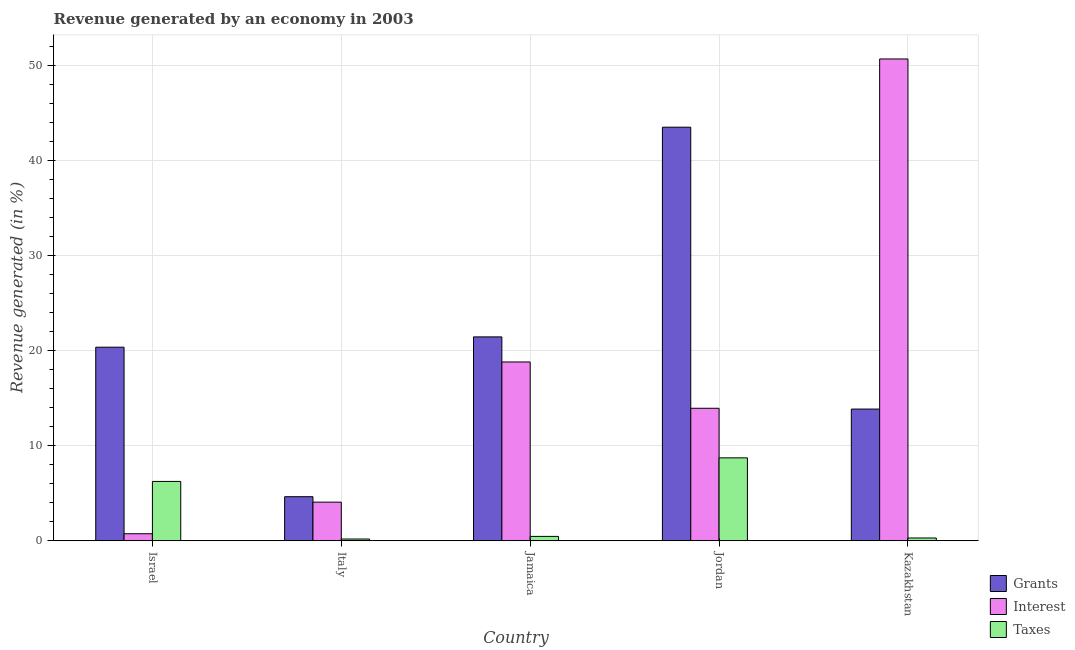Are the number of bars per tick equal to the number of legend labels?
Give a very brief answer. Yes. How many bars are there on the 2nd tick from the right?
Ensure brevity in your answer.  3. What is the label of the 5th group of bars from the left?
Offer a very short reply. Kazakhstan. In how many cases, is the number of bars for a given country not equal to the number of legend labels?
Give a very brief answer. 0. What is the percentage of revenue generated by interest in Kazakhstan?
Provide a short and direct response. 50.67. Across all countries, what is the maximum percentage of revenue generated by taxes?
Offer a terse response. 8.72. Across all countries, what is the minimum percentage of revenue generated by interest?
Ensure brevity in your answer.  0.73. In which country was the percentage of revenue generated by interest maximum?
Ensure brevity in your answer.  Kazakhstan. What is the total percentage of revenue generated by grants in the graph?
Ensure brevity in your answer.  103.77. What is the difference between the percentage of revenue generated by taxes in Italy and that in Kazakhstan?
Give a very brief answer. -0.11. What is the difference between the percentage of revenue generated by grants in Italy and the percentage of revenue generated by taxes in Jamaica?
Provide a succinct answer. 4.18. What is the average percentage of revenue generated by grants per country?
Ensure brevity in your answer.  20.75. What is the difference between the percentage of revenue generated by grants and percentage of revenue generated by interest in Jamaica?
Provide a short and direct response. 2.64. What is the ratio of the percentage of revenue generated by grants in Israel to that in Jordan?
Your response must be concise. 0.47. Is the percentage of revenue generated by taxes in Israel less than that in Jamaica?
Your response must be concise. No. Is the difference between the percentage of revenue generated by grants in Israel and Italy greater than the difference between the percentage of revenue generated by interest in Israel and Italy?
Your response must be concise. Yes. What is the difference between the highest and the second highest percentage of revenue generated by grants?
Offer a terse response. 22.06. What is the difference between the highest and the lowest percentage of revenue generated by interest?
Keep it short and to the point. 49.94. In how many countries, is the percentage of revenue generated by interest greater than the average percentage of revenue generated by interest taken over all countries?
Your answer should be very brief. 2. Is the sum of the percentage of revenue generated by grants in Italy and Jamaica greater than the maximum percentage of revenue generated by interest across all countries?
Provide a short and direct response. No. What does the 1st bar from the left in Jordan represents?
Your answer should be compact. Grants. What does the 1st bar from the right in Jordan represents?
Give a very brief answer. Taxes. What is the difference between two consecutive major ticks on the Y-axis?
Your answer should be compact. 10. Are the values on the major ticks of Y-axis written in scientific E-notation?
Give a very brief answer. No. Does the graph contain any zero values?
Provide a succinct answer. No. How many legend labels are there?
Your answer should be compact. 3. How are the legend labels stacked?
Keep it short and to the point. Vertical. What is the title of the graph?
Ensure brevity in your answer.  Revenue generated by an economy in 2003. Does "Tertiary" appear as one of the legend labels in the graph?
Provide a succinct answer. No. What is the label or title of the Y-axis?
Offer a terse response. Revenue generated (in %). What is the Revenue generated (in %) of Grants in Israel?
Keep it short and to the point. 20.35. What is the Revenue generated (in %) of Interest in Israel?
Your response must be concise. 0.73. What is the Revenue generated (in %) of Taxes in Israel?
Ensure brevity in your answer.  6.24. What is the Revenue generated (in %) of Grants in Italy?
Your answer should be compact. 4.63. What is the Revenue generated (in %) of Interest in Italy?
Give a very brief answer. 4.06. What is the Revenue generated (in %) in Taxes in Italy?
Make the answer very short. 0.18. What is the Revenue generated (in %) of Grants in Jamaica?
Provide a succinct answer. 21.44. What is the Revenue generated (in %) in Interest in Jamaica?
Your answer should be compact. 18.8. What is the Revenue generated (in %) in Taxes in Jamaica?
Make the answer very short. 0.45. What is the Revenue generated (in %) of Grants in Jordan?
Provide a succinct answer. 43.49. What is the Revenue generated (in %) in Interest in Jordan?
Ensure brevity in your answer.  13.93. What is the Revenue generated (in %) of Taxes in Jordan?
Your response must be concise. 8.72. What is the Revenue generated (in %) of Grants in Kazakhstan?
Offer a very short reply. 13.85. What is the Revenue generated (in %) in Interest in Kazakhstan?
Offer a terse response. 50.67. What is the Revenue generated (in %) in Taxes in Kazakhstan?
Keep it short and to the point. 0.29. Across all countries, what is the maximum Revenue generated (in %) in Grants?
Your answer should be compact. 43.49. Across all countries, what is the maximum Revenue generated (in %) in Interest?
Offer a terse response. 50.67. Across all countries, what is the maximum Revenue generated (in %) in Taxes?
Your answer should be compact. 8.72. Across all countries, what is the minimum Revenue generated (in %) of Grants?
Your response must be concise. 4.63. Across all countries, what is the minimum Revenue generated (in %) of Interest?
Ensure brevity in your answer.  0.73. Across all countries, what is the minimum Revenue generated (in %) of Taxes?
Offer a very short reply. 0.18. What is the total Revenue generated (in %) in Grants in the graph?
Make the answer very short. 103.77. What is the total Revenue generated (in %) of Interest in the graph?
Give a very brief answer. 88.19. What is the total Revenue generated (in %) of Taxes in the graph?
Give a very brief answer. 15.87. What is the difference between the Revenue generated (in %) of Grants in Israel and that in Italy?
Give a very brief answer. 15.72. What is the difference between the Revenue generated (in %) of Interest in Israel and that in Italy?
Offer a terse response. -3.32. What is the difference between the Revenue generated (in %) of Taxes in Israel and that in Italy?
Offer a terse response. 6.06. What is the difference between the Revenue generated (in %) of Grants in Israel and that in Jamaica?
Give a very brief answer. -1.09. What is the difference between the Revenue generated (in %) in Interest in Israel and that in Jamaica?
Your answer should be compact. -18.07. What is the difference between the Revenue generated (in %) of Taxes in Israel and that in Jamaica?
Offer a very short reply. 5.78. What is the difference between the Revenue generated (in %) of Grants in Israel and that in Jordan?
Your answer should be very brief. -23.14. What is the difference between the Revenue generated (in %) of Interest in Israel and that in Jordan?
Offer a terse response. -13.2. What is the difference between the Revenue generated (in %) of Taxes in Israel and that in Jordan?
Your answer should be very brief. -2.48. What is the difference between the Revenue generated (in %) of Grants in Israel and that in Kazakhstan?
Make the answer very short. 6.51. What is the difference between the Revenue generated (in %) of Interest in Israel and that in Kazakhstan?
Your answer should be compact. -49.94. What is the difference between the Revenue generated (in %) in Taxes in Israel and that in Kazakhstan?
Give a very brief answer. 5.95. What is the difference between the Revenue generated (in %) in Grants in Italy and that in Jamaica?
Provide a short and direct response. -16.81. What is the difference between the Revenue generated (in %) in Interest in Italy and that in Jamaica?
Offer a terse response. -14.74. What is the difference between the Revenue generated (in %) in Taxes in Italy and that in Jamaica?
Provide a succinct answer. -0.28. What is the difference between the Revenue generated (in %) of Grants in Italy and that in Jordan?
Ensure brevity in your answer.  -38.86. What is the difference between the Revenue generated (in %) of Interest in Italy and that in Jordan?
Give a very brief answer. -9.87. What is the difference between the Revenue generated (in %) in Taxes in Italy and that in Jordan?
Your answer should be very brief. -8.54. What is the difference between the Revenue generated (in %) of Grants in Italy and that in Kazakhstan?
Your answer should be very brief. -9.22. What is the difference between the Revenue generated (in %) of Interest in Italy and that in Kazakhstan?
Ensure brevity in your answer.  -46.61. What is the difference between the Revenue generated (in %) in Taxes in Italy and that in Kazakhstan?
Make the answer very short. -0.11. What is the difference between the Revenue generated (in %) of Grants in Jamaica and that in Jordan?
Provide a short and direct response. -22.06. What is the difference between the Revenue generated (in %) of Interest in Jamaica and that in Jordan?
Your answer should be compact. 4.87. What is the difference between the Revenue generated (in %) of Taxes in Jamaica and that in Jordan?
Offer a terse response. -8.26. What is the difference between the Revenue generated (in %) of Grants in Jamaica and that in Kazakhstan?
Ensure brevity in your answer.  7.59. What is the difference between the Revenue generated (in %) in Interest in Jamaica and that in Kazakhstan?
Provide a short and direct response. -31.87. What is the difference between the Revenue generated (in %) of Taxes in Jamaica and that in Kazakhstan?
Your answer should be compact. 0.17. What is the difference between the Revenue generated (in %) of Grants in Jordan and that in Kazakhstan?
Your response must be concise. 29.65. What is the difference between the Revenue generated (in %) in Interest in Jordan and that in Kazakhstan?
Your response must be concise. -36.74. What is the difference between the Revenue generated (in %) in Taxes in Jordan and that in Kazakhstan?
Provide a short and direct response. 8.43. What is the difference between the Revenue generated (in %) of Grants in Israel and the Revenue generated (in %) of Interest in Italy?
Ensure brevity in your answer.  16.3. What is the difference between the Revenue generated (in %) of Grants in Israel and the Revenue generated (in %) of Taxes in Italy?
Offer a terse response. 20.18. What is the difference between the Revenue generated (in %) of Interest in Israel and the Revenue generated (in %) of Taxes in Italy?
Provide a short and direct response. 0.55. What is the difference between the Revenue generated (in %) in Grants in Israel and the Revenue generated (in %) in Interest in Jamaica?
Your response must be concise. 1.55. What is the difference between the Revenue generated (in %) in Grants in Israel and the Revenue generated (in %) in Taxes in Jamaica?
Offer a terse response. 19.9. What is the difference between the Revenue generated (in %) in Interest in Israel and the Revenue generated (in %) in Taxes in Jamaica?
Ensure brevity in your answer.  0.28. What is the difference between the Revenue generated (in %) of Grants in Israel and the Revenue generated (in %) of Interest in Jordan?
Offer a very short reply. 6.42. What is the difference between the Revenue generated (in %) of Grants in Israel and the Revenue generated (in %) of Taxes in Jordan?
Provide a succinct answer. 11.64. What is the difference between the Revenue generated (in %) of Interest in Israel and the Revenue generated (in %) of Taxes in Jordan?
Your response must be concise. -7.98. What is the difference between the Revenue generated (in %) in Grants in Israel and the Revenue generated (in %) in Interest in Kazakhstan?
Ensure brevity in your answer.  -30.32. What is the difference between the Revenue generated (in %) of Grants in Israel and the Revenue generated (in %) of Taxes in Kazakhstan?
Ensure brevity in your answer.  20.07. What is the difference between the Revenue generated (in %) in Interest in Israel and the Revenue generated (in %) in Taxes in Kazakhstan?
Your answer should be very brief. 0.45. What is the difference between the Revenue generated (in %) of Grants in Italy and the Revenue generated (in %) of Interest in Jamaica?
Your response must be concise. -14.17. What is the difference between the Revenue generated (in %) in Grants in Italy and the Revenue generated (in %) in Taxes in Jamaica?
Make the answer very short. 4.18. What is the difference between the Revenue generated (in %) of Interest in Italy and the Revenue generated (in %) of Taxes in Jamaica?
Offer a very short reply. 3.6. What is the difference between the Revenue generated (in %) in Grants in Italy and the Revenue generated (in %) in Interest in Jordan?
Your answer should be compact. -9.3. What is the difference between the Revenue generated (in %) in Grants in Italy and the Revenue generated (in %) in Taxes in Jordan?
Ensure brevity in your answer.  -4.09. What is the difference between the Revenue generated (in %) of Interest in Italy and the Revenue generated (in %) of Taxes in Jordan?
Give a very brief answer. -4.66. What is the difference between the Revenue generated (in %) of Grants in Italy and the Revenue generated (in %) of Interest in Kazakhstan?
Give a very brief answer. -46.04. What is the difference between the Revenue generated (in %) of Grants in Italy and the Revenue generated (in %) of Taxes in Kazakhstan?
Ensure brevity in your answer.  4.34. What is the difference between the Revenue generated (in %) in Interest in Italy and the Revenue generated (in %) in Taxes in Kazakhstan?
Make the answer very short. 3.77. What is the difference between the Revenue generated (in %) in Grants in Jamaica and the Revenue generated (in %) in Interest in Jordan?
Your response must be concise. 7.51. What is the difference between the Revenue generated (in %) in Grants in Jamaica and the Revenue generated (in %) in Taxes in Jordan?
Keep it short and to the point. 12.72. What is the difference between the Revenue generated (in %) in Interest in Jamaica and the Revenue generated (in %) in Taxes in Jordan?
Offer a terse response. 10.09. What is the difference between the Revenue generated (in %) in Grants in Jamaica and the Revenue generated (in %) in Interest in Kazakhstan?
Ensure brevity in your answer.  -29.23. What is the difference between the Revenue generated (in %) in Grants in Jamaica and the Revenue generated (in %) in Taxes in Kazakhstan?
Provide a short and direct response. 21.15. What is the difference between the Revenue generated (in %) in Interest in Jamaica and the Revenue generated (in %) in Taxes in Kazakhstan?
Your response must be concise. 18.51. What is the difference between the Revenue generated (in %) of Grants in Jordan and the Revenue generated (in %) of Interest in Kazakhstan?
Offer a terse response. -7.18. What is the difference between the Revenue generated (in %) in Grants in Jordan and the Revenue generated (in %) in Taxes in Kazakhstan?
Your answer should be compact. 43.21. What is the difference between the Revenue generated (in %) in Interest in Jordan and the Revenue generated (in %) in Taxes in Kazakhstan?
Offer a terse response. 13.64. What is the average Revenue generated (in %) in Grants per country?
Your answer should be very brief. 20.75. What is the average Revenue generated (in %) of Interest per country?
Make the answer very short. 17.64. What is the average Revenue generated (in %) in Taxes per country?
Ensure brevity in your answer.  3.17. What is the difference between the Revenue generated (in %) in Grants and Revenue generated (in %) in Interest in Israel?
Your answer should be very brief. 19.62. What is the difference between the Revenue generated (in %) in Grants and Revenue generated (in %) in Taxes in Israel?
Your response must be concise. 14.12. What is the difference between the Revenue generated (in %) in Interest and Revenue generated (in %) in Taxes in Israel?
Provide a short and direct response. -5.5. What is the difference between the Revenue generated (in %) in Grants and Revenue generated (in %) in Interest in Italy?
Provide a succinct answer. 0.57. What is the difference between the Revenue generated (in %) in Grants and Revenue generated (in %) in Taxes in Italy?
Keep it short and to the point. 4.45. What is the difference between the Revenue generated (in %) of Interest and Revenue generated (in %) of Taxes in Italy?
Your answer should be very brief. 3.88. What is the difference between the Revenue generated (in %) of Grants and Revenue generated (in %) of Interest in Jamaica?
Keep it short and to the point. 2.64. What is the difference between the Revenue generated (in %) in Grants and Revenue generated (in %) in Taxes in Jamaica?
Your answer should be very brief. 20.98. What is the difference between the Revenue generated (in %) in Interest and Revenue generated (in %) in Taxes in Jamaica?
Your response must be concise. 18.35. What is the difference between the Revenue generated (in %) of Grants and Revenue generated (in %) of Interest in Jordan?
Make the answer very short. 29.56. What is the difference between the Revenue generated (in %) in Grants and Revenue generated (in %) in Taxes in Jordan?
Ensure brevity in your answer.  34.78. What is the difference between the Revenue generated (in %) of Interest and Revenue generated (in %) of Taxes in Jordan?
Offer a terse response. 5.22. What is the difference between the Revenue generated (in %) of Grants and Revenue generated (in %) of Interest in Kazakhstan?
Provide a short and direct response. -36.82. What is the difference between the Revenue generated (in %) of Grants and Revenue generated (in %) of Taxes in Kazakhstan?
Provide a succinct answer. 13.56. What is the difference between the Revenue generated (in %) in Interest and Revenue generated (in %) in Taxes in Kazakhstan?
Your response must be concise. 50.38. What is the ratio of the Revenue generated (in %) in Grants in Israel to that in Italy?
Provide a succinct answer. 4.4. What is the ratio of the Revenue generated (in %) of Interest in Israel to that in Italy?
Your response must be concise. 0.18. What is the ratio of the Revenue generated (in %) of Taxes in Israel to that in Italy?
Give a very brief answer. 34.93. What is the ratio of the Revenue generated (in %) of Grants in Israel to that in Jamaica?
Your answer should be compact. 0.95. What is the ratio of the Revenue generated (in %) in Interest in Israel to that in Jamaica?
Provide a succinct answer. 0.04. What is the ratio of the Revenue generated (in %) of Taxes in Israel to that in Jamaica?
Offer a terse response. 13.72. What is the ratio of the Revenue generated (in %) in Grants in Israel to that in Jordan?
Ensure brevity in your answer.  0.47. What is the ratio of the Revenue generated (in %) of Interest in Israel to that in Jordan?
Your answer should be very brief. 0.05. What is the ratio of the Revenue generated (in %) of Taxes in Israel to that in Jordan?
Ensure brevity in your answer.  0.72. What is the ratio of the Revenue generated (in %) in Grants in Israel to that in Kazakhstan?
Make the answer very short. 1.47. What is the ratio of the Revenue generated (in %) in Interest in Israel to that in Kazakhstan?
Provide a short and direct response. 0.01. What is the ratio of the Revenue generated (in %) of Taxes in Israel to that in Kazakhstan?
Offer a very short reply. 21.71. What is the ratio of the Revenue generated (in %) in Grants in Italy to that in Jamaica?
Your answer should be compact. 0.22. What is the ratio of the Revenue generated (in %) of Interest in Italy to that in Jamaica?
Make the answer very short. 0.22. What is the ratio of the Revenue generated (in %) in Taxes in Italy to that in Jamaica?
Give a very brief answer. 0.39. What is the ratio of the Revenue generated (in %) of Grants in Italy to that in Jordan?
Provide a succinct answer. 0.11. What is the ratio of the Revenue generated (in %) in Interest in Italy to that in Jordan?
Your answer should be very brief. 0.29. What is the ratio of the Revenue generated (in %) in Taxes in Italy to that in Jordan?
Give a very brief answer. 0.02. What is the ratio of the Revenue generated (in %) of Grants in Italy to that in Kazakhstan?
Make the answer very short. 0.33. What is the ratio of the Revenue generated (in %) of Interest in Italy to that in Kazakhstan?
Offer a terse response. 0.08. What is the ratio of the Revenue generated (in %) in Taxes in Italy to that in Kazakhstan?
Your response must be concise. 0.62. What is the ratio of the Revenue generated (in %) in Grants in Jamaica to that in Jordan?
Give a very brief answer. 0.49. What is the ratio of the Revenue generated (in %) of Interest in Jamaica to that in Jordan?
Provide a succinct answer. 1.35. What is the ratio of the Revenue generated (in %) in Taxes in Jamaica to that in Jordan?
Offer a very short reply. 0.05. What is the ratio of the Revenue generated (in %) of Grants in Jamaica to that in Kazakhstan?
Offer a terse response. 1.55. What is the ratio of the Revenue generated (in %) of Interest in Jamaica to that in Kazakhstan?
Your answer should be compact. 0.37. What is the ratio of the Revenue generated (in %) of Taxes in Jamaica to that in Kazakhstan?
Your response must be concise. 1.58. What is the ratio of the Revenue generated (in %) in Grants in Jordan to that in Kazakhstan?
Give a very brief answer. 3.14. What is the ratio of the Revenue generated (in %) in Interest in Jordan to that in Kazakhstan?
Offer a very short reply. 0.27. What is the ratio of the Revenue generated (in %) in Taxes in Jordan to that in Kazakhstan?
Give a very brief answer. 30.34. What is the difference between the highest and the second highest Revenue generated (in %) in Grants?
Your answer should be very brief. 22.06. What is the difference between the highest and the second highest Revenue generated (in %) of Interest?
Your response must be concise. 31.87. What is the difference between the highest and the second highest Revenue generated (in %) of Taxes?
Provide a succinct answer. 2.48. What is the difference between the highest and the lowest Revenue generated (in %) of Grants?
Offer a terse response. 38.86. What is the difference between the highest and the lowest Revenue generated (in %) in Interest?
Provide a succinct answer. 49.94. What is the difference between the highest and the lowest Revenue generated (in %) of Taxes?
Ensure brevity in your answer.  8.54. 